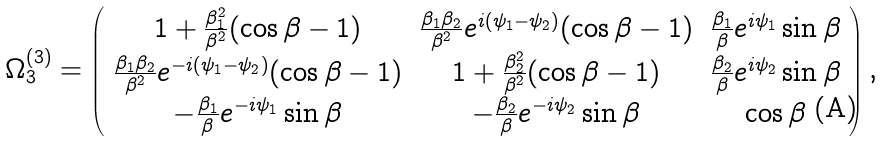<formula> <loc_0><loc_0><loc_500><loc_500>\Omega _ { 3 } ^ { ( 3 ) } = \left ( \begin{array} { c c c } 1 + \frac { \beta _ { 1 } ^ { 2 } } { \beta ^ { 2 } } ( \cos { \beta } - 1 ) & \frac { \beta _ { 1 } \beta _ { 2 } } { \beta ^ { 2 } } e ^ { i ( \psi _ { 1 } - \psi _ { 2 } ) } ( \cos { \beta } - 1 ) & \frac { \beta _ { 1 } } { \beta } e ^ { i \psi _ { 1 } } \sin { \beta } \\ \frac { \beta _ { 1 } \beta _ { 2 } } { \beta ^ { 2 } } e ^ { - i ( \psi _ { 1 } - \psi _ { 2 } ) } ( \cos { \beta } - 1 ) & 1 + \frac { \beta _ { 2 } ^ { 2 } } { \beta ^ { 2 } } ( \cos { \beta } - 1 ) & \frac { \beta _ { 2 } } { \beta } e ^ { i \psi _ { 2 } } \sin { \beta } \\ - \frac { \beta _ { 1 } } { \beta } e ^ { - i \psi _ { 1 } } \sin { \beta } & - \frac { \beta _ { 2 } } { \beta } e ^ { - i \psi _ { 2 } } \sin { \beta } & \cos { \beta } \end{array} \right ) ,</formula> 